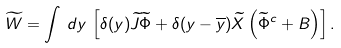Convert formula to latex. <formula><loc_0><loc_0><loc_500><loc_500>\widetilde { W } = \int \, d y \, \left [ \delta ( y ) \widetilde { J } \widetilde { \Phi } + \delta ( y - \overline { y } ) \widetilde { X } \left ( \widetilde { \Phi } ^ { c } + B \right ) \right ] .</formula> 